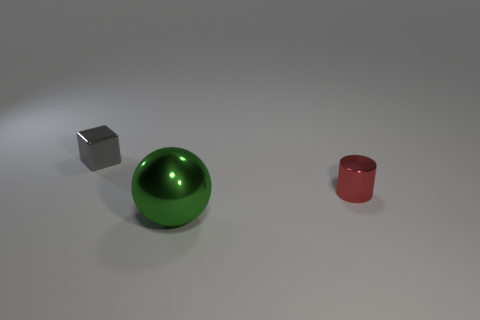What colors are present in the scene, and how do they affect the mood of the image? The scene includes a muted grey floor, a metallic silver cube, a vibrant green sphere, and a glossy red cylinder. The combination of these colors against the neutral background gives the image a calm yet dynamic quality, as the bright green and red provide focal points that stand out from the otherwise understated tones. 